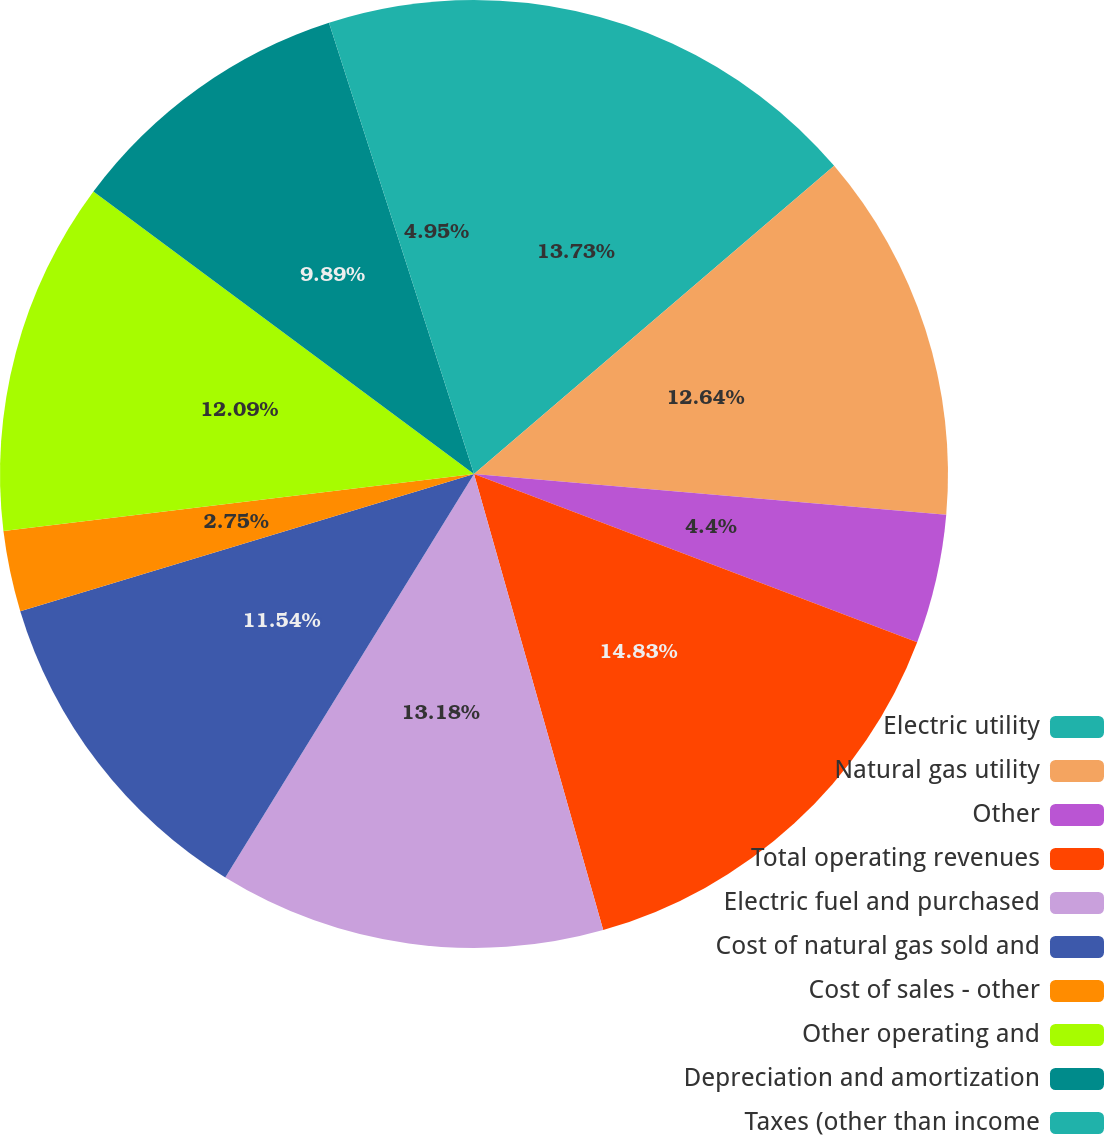Convert chart to OTSL. <chart><loc_0><loc_0><loc_500><loc_500><pie_chart><fcel>Electric utility<fcel>Natural gas utility<fcel>Other<fcel>Total operating revenues<fcel>Electric fuel and purchased<fcel>Cost of natural gas sold and<fcel>Cost of sales - other<fcel>Other operating and<fcel>Depreciation and amortization<fcel>Taxes (other than income<nl><fcel>13.74%<fcel>12.64%<fcel>4.4%<fcel>14.84%<fcel>13.19%<fcel>11.54%<fcel>2.75%<fcel>12.09%<fcel>9.89%<fcel>4.95%<nl></chart> 